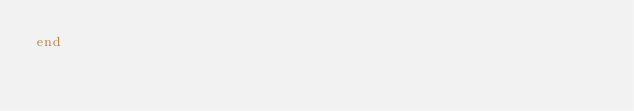<code> <loc_0><loc_0><loc_500><loc_500><_Ruby_>end
</code> 